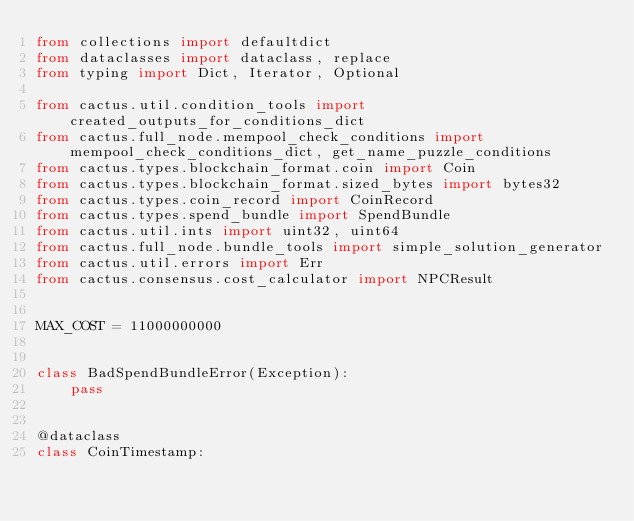Convert code to text. <code><loc_0><loc_0><loc_500><loc_500><_Python_>from collections import defaultdict
from dataclasses import dataclass, replace
from typing import Dict, Iterator, Optional

from cactus.util.condition_tools import created_outputs_for_conditions_dict
from cactus.full_node.mempool_check_conditions import mempool_check_conditions_dict, get_name_puzzle_conditions
from cactus.types.blockchain_format.coin import Coin
from cactus.types.blockchain_format.sized_bytes import bytes32
from cactus.types.coin_record import CoinRecord
from cactus.types.spend_bundle import SpendBundle
from cactus.util.ints import uint32, uint64
from cactus.full_node.bundle_tools import simple_solution_generator
from cactus.util.errors import Err
from cactus.consensus.cost_calculator import NPCResult


MAX_COST = 11000000000


class BadSpendBundleError(Exception):
    pass


@dataclass
class CoinTimestamp:</code> 